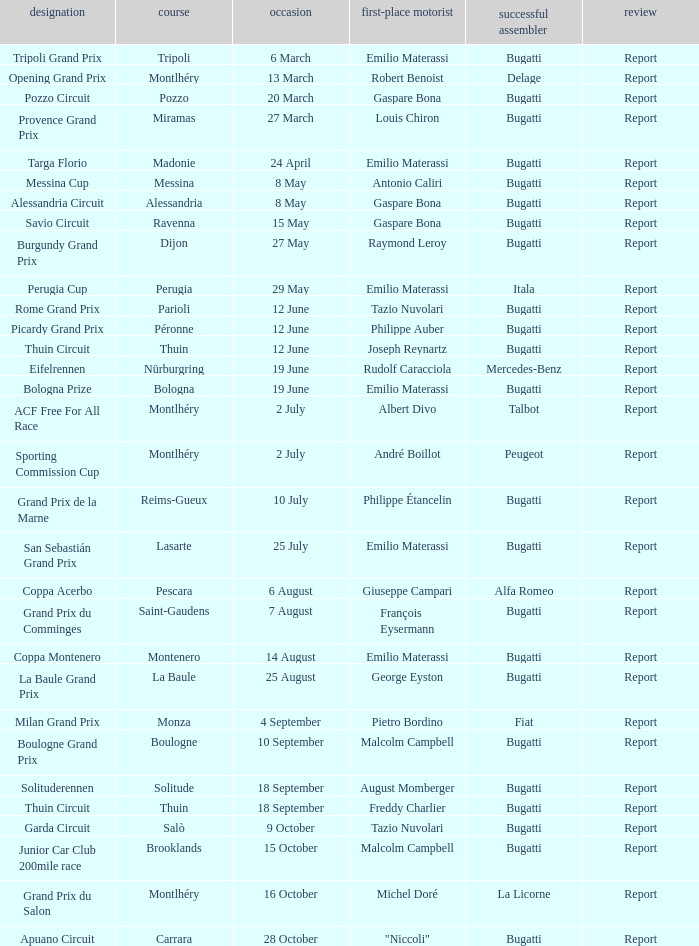Which circuit did françois eysermann win ? Saint-Gaudens. 